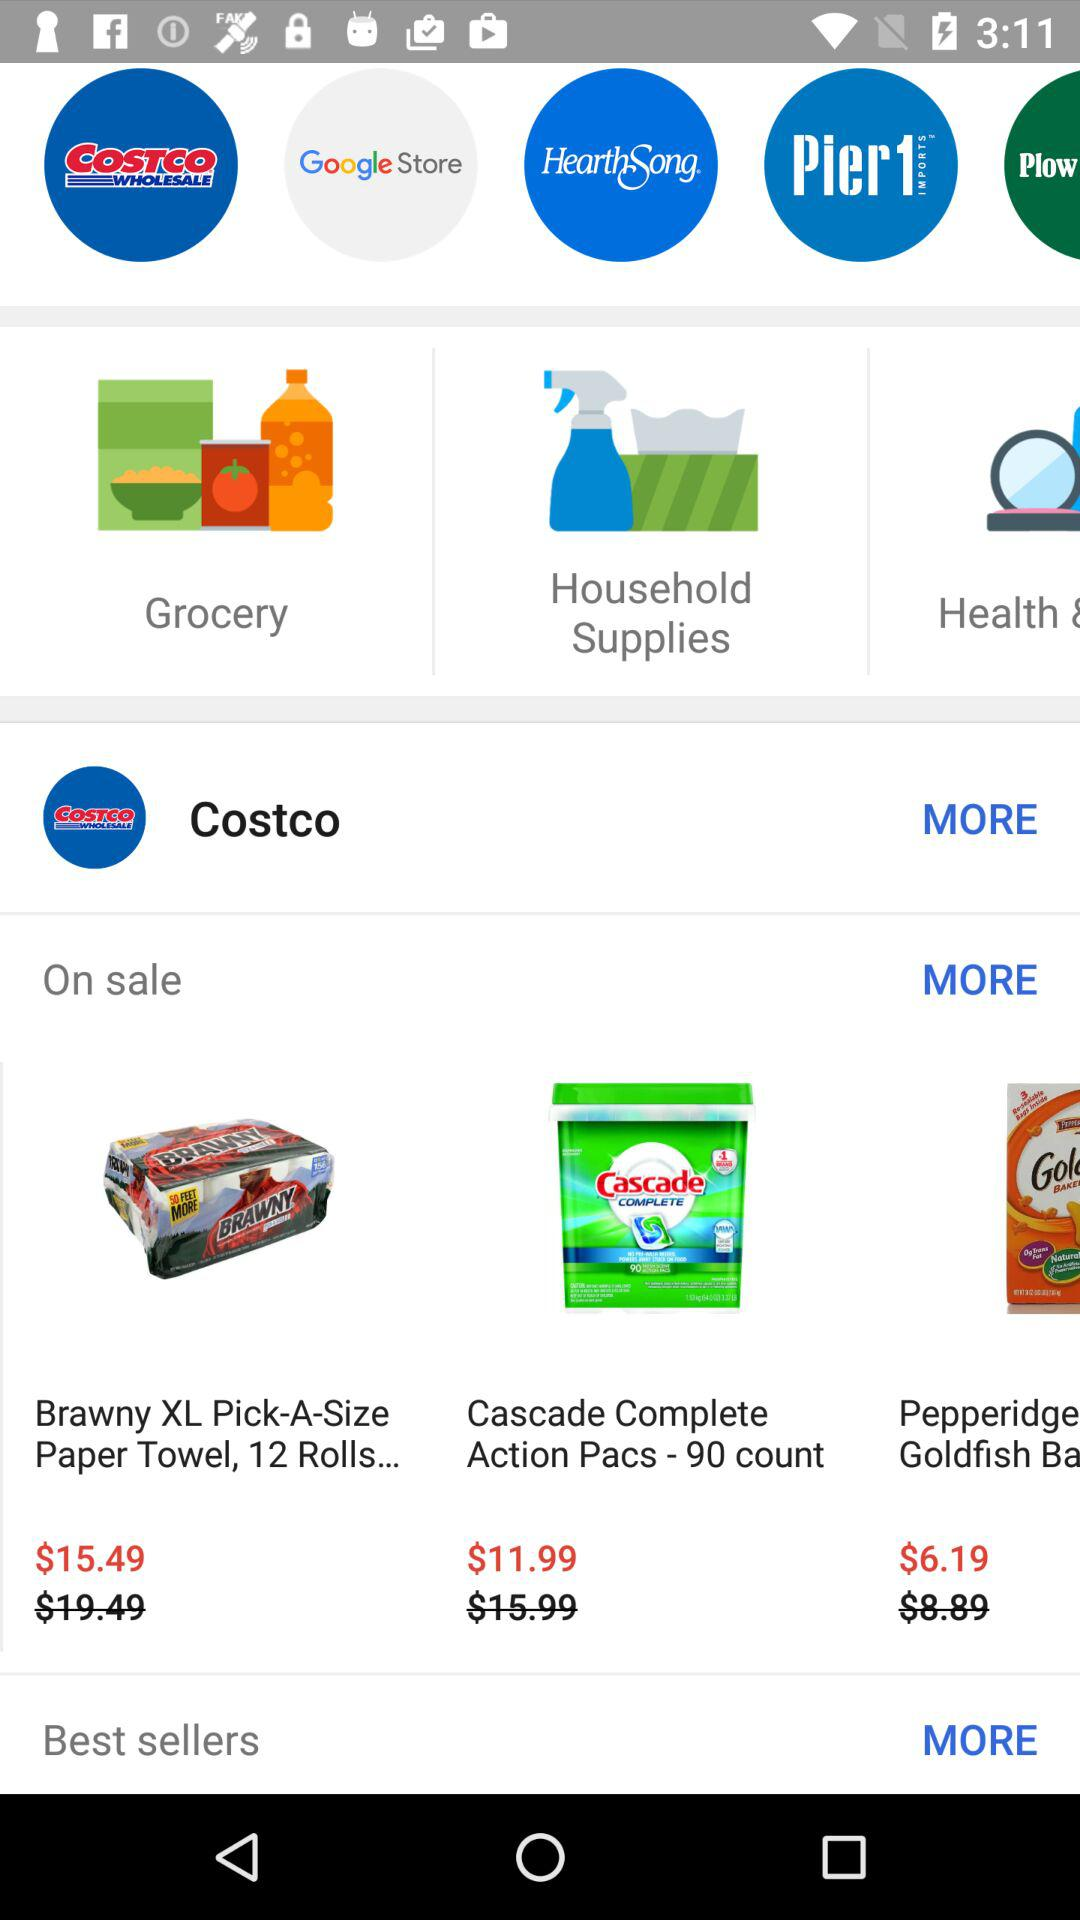What is the discounted price of "Cascade Complete Action Pacs - 90 count"? The discounted price is $11.99. 